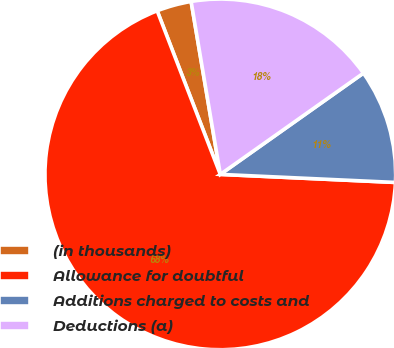Convert chart to OTSL. <chart><loc_0><loc_0><loc_500><loc_500><pie_chart><fcel>(in thousands)<fcel>Allowance for doubtful<fcel>Additions charged to costs and<fcel>Deductions (a)<nl><fcel>3.2%<fcel>68.4%<fcel>10.53%<fcel>17.86%<nl></chart> 